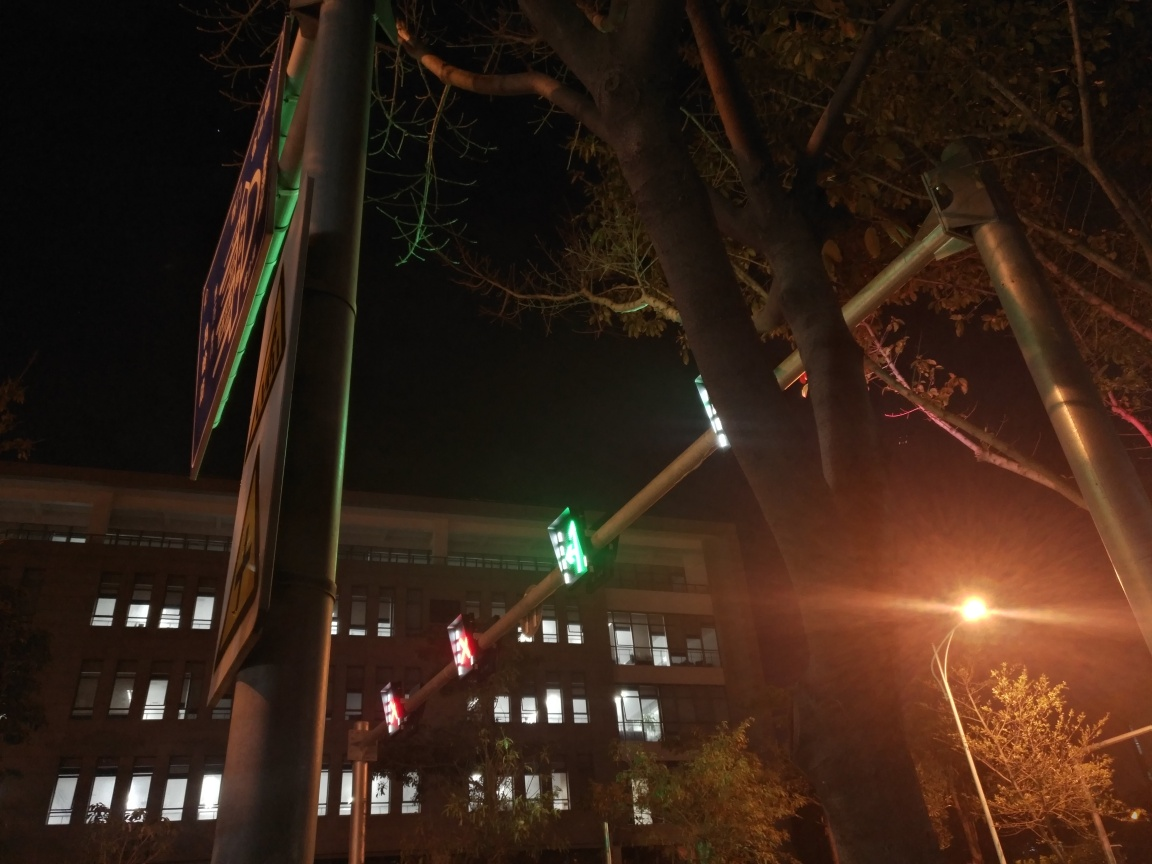Are the textures of building walls visible? The textures of the building walls are not clearly visible due to the nighttime lighting conditions and the focus of the image on the illuminated street signs and traffic lights in the foreground. 